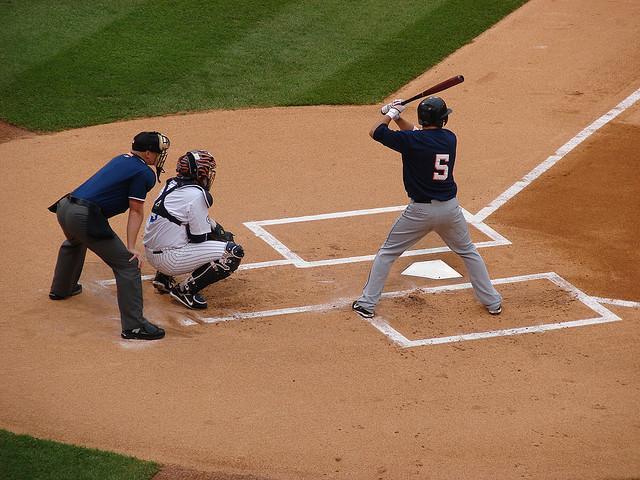Rawlings are the helmets used by whom?
Select the accurate answer and provide justification: `Answer: choice
Rationale: srationale.`
Options: Bbl, mlb, ttb, bsl. Answer: mlb.
Rationale: The answer is internet searchable. 